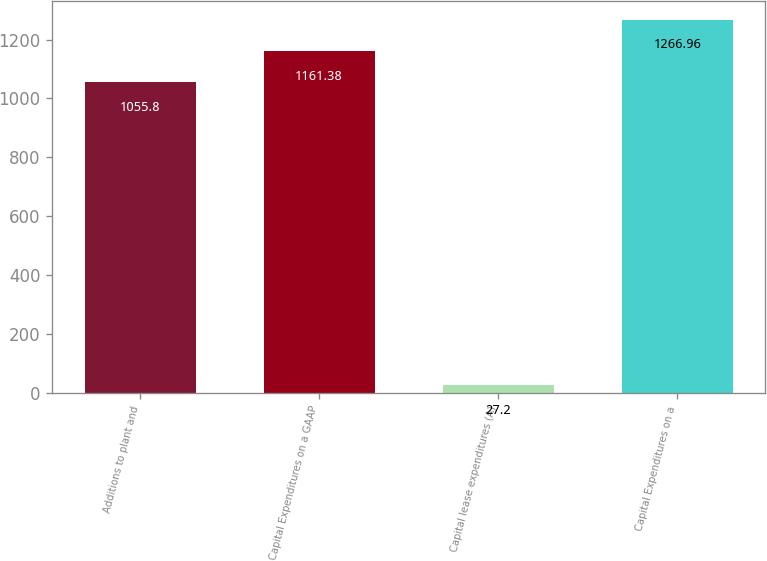Convert chart. <chart><loc_0><loc_0><loc_500><loc_500><bar_chart><fcel>Additions to plant and<fcel>Capital Expenditures on a GAAP<fcel>Capital lease expenditures (A)<fcel>Capital Expenditures on a<nl><fcel>1055.8<fcel>1161.38<fcel>27.2<fcel>1266.96<nl></chart> 